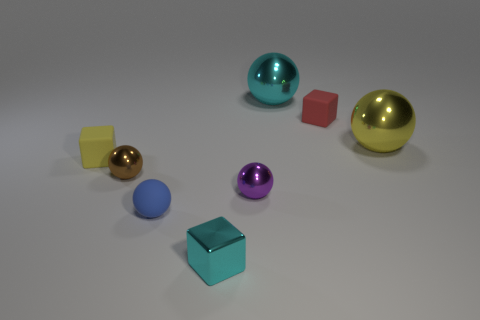Is there a tiny cube that has the same material as the yellow sphere?
Offer a very short reply. Yes. There is a purple thing that is the same size as the brown sphere; what is its material?
Ensure brevity in your answer.  Metal. Is the number of balls behind the tiny brown shiny ball less than the number of objects that are in front of the red block?
Ensure brevity in your answer.  Yes. What is the shape of the small thing that is both to the left of the blue rubber ball and in front of the small yellow rubber thing?
Make the answer very short. Sphere. How many large cyan metal objects are the same shape as the tiny brown metal thing?
Provide a short and direct response. 1. The red object that is the same material as the tiny blue sphere is what size?
Offer a terse response. Small. Is the number of cyan cubes greater than the number of rubber objects?
Offer a terse response. No. What is the color of the thing on the left side of the small brown object?
Your answer should be compact. Yellow. What size is the rubber object that is both behind the rubber sphere and to the left of the tiny cyan cube?
Make the answer very short. Small. How many yellow rubber things have the same size as the cyan cube?
Your response must be concise. 1. 